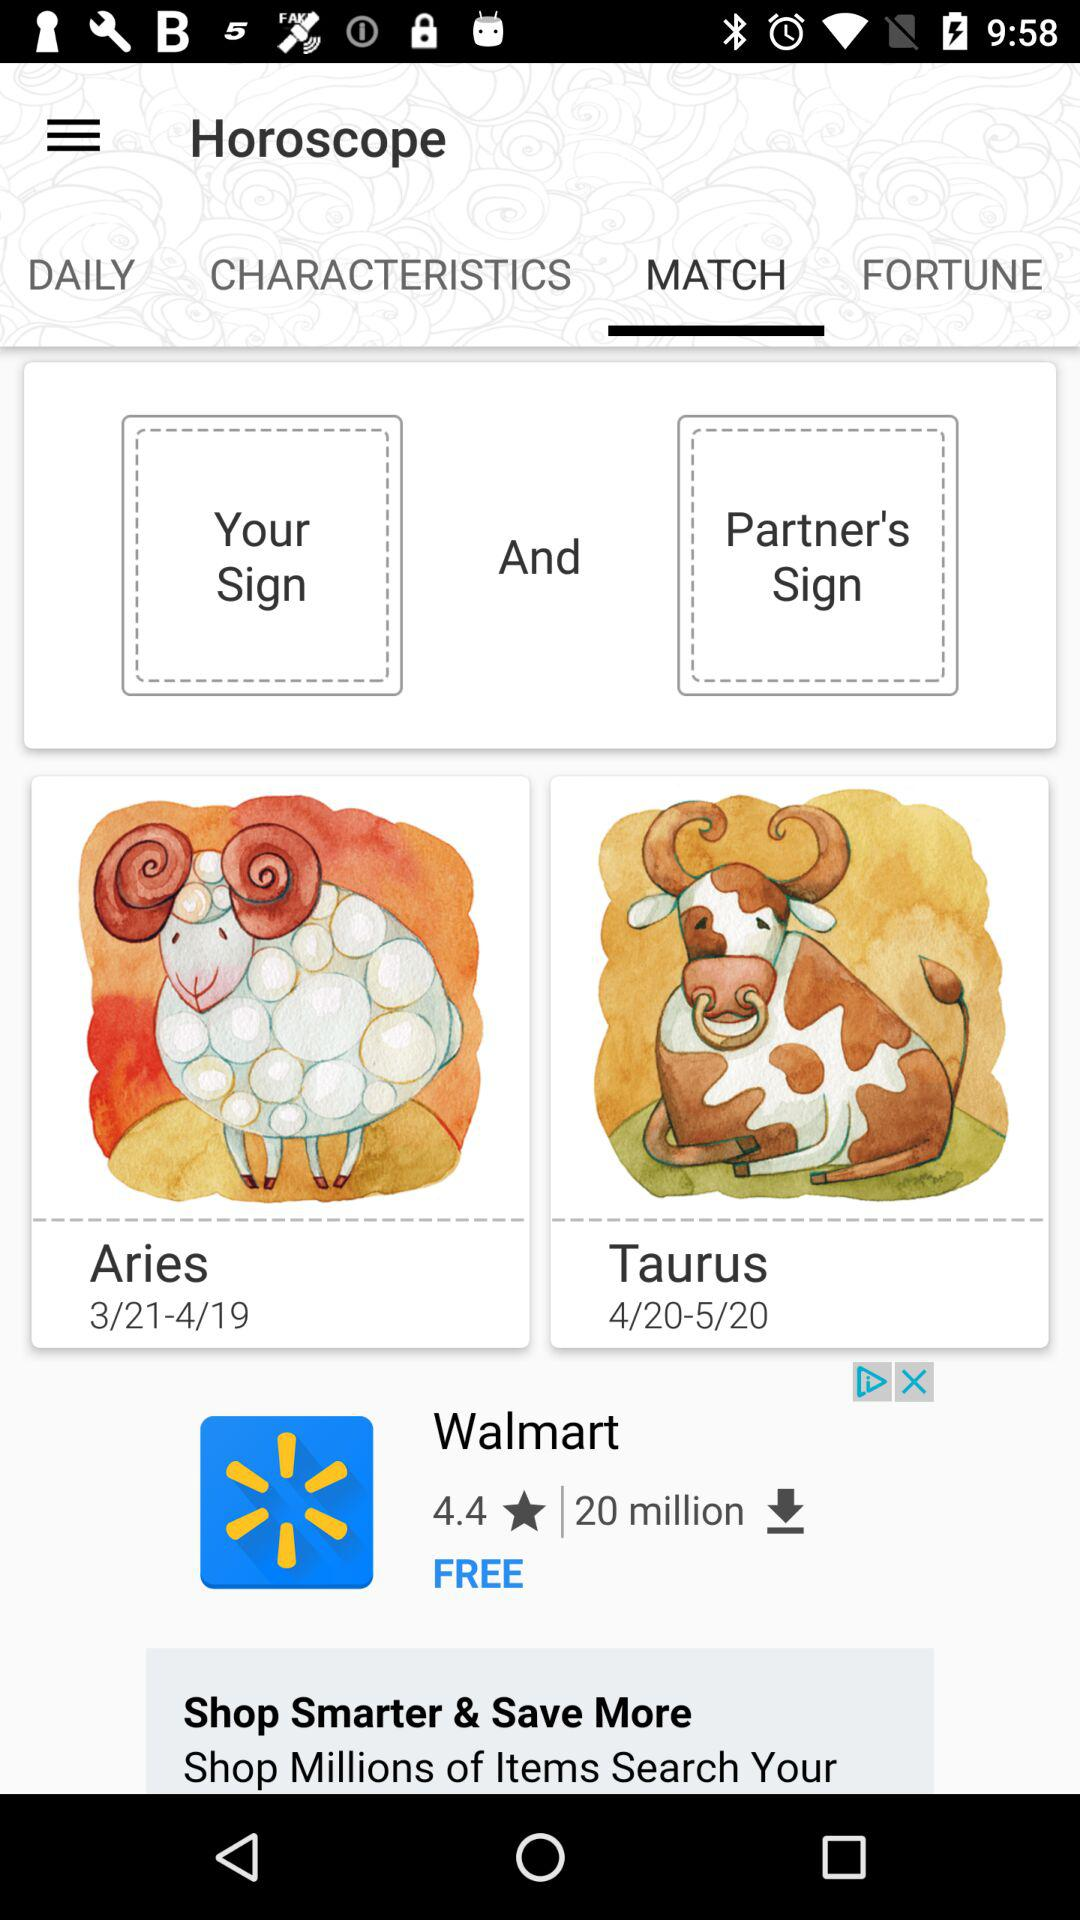Which tab am I using? You are using the "MATCH" tab. 